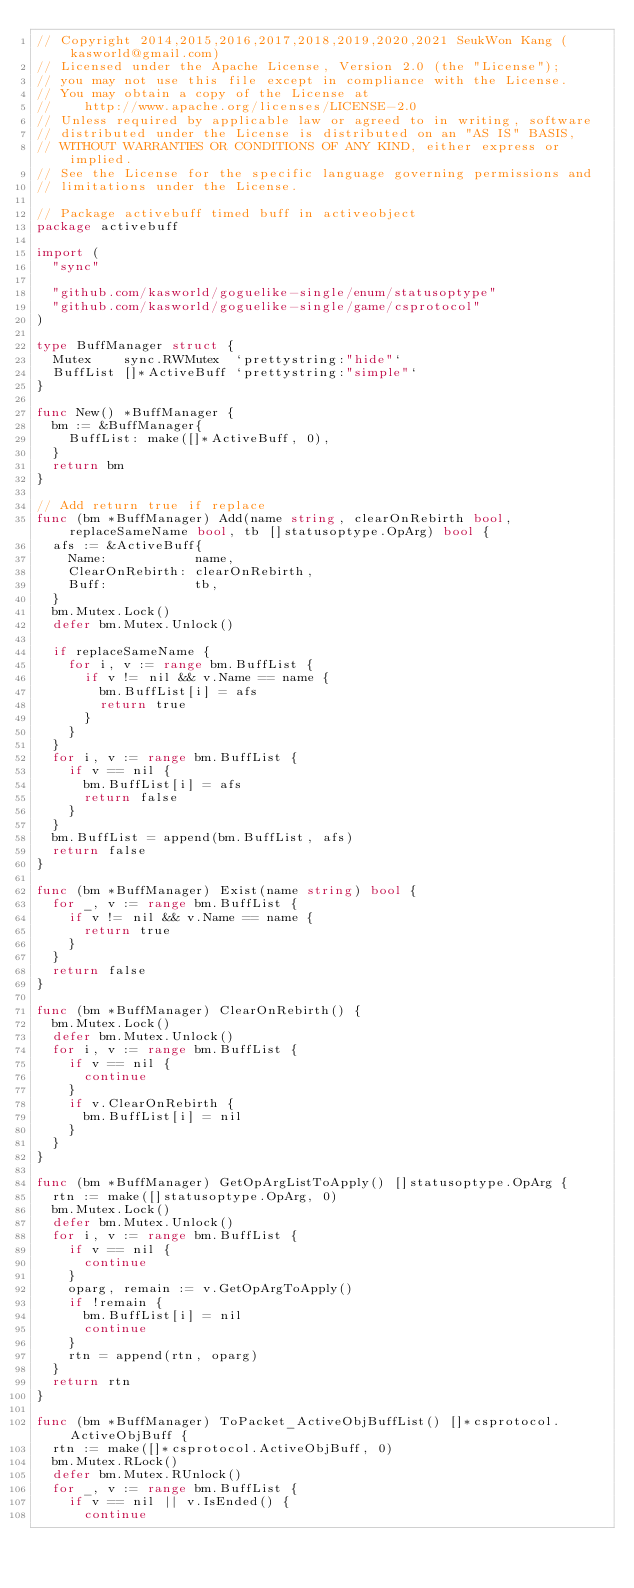Convert code to text. <code><loc_0><loc_0><loc_500><loc_500><_Go_>// Copyright 2014,2015,2016,2017,2018,2019,2020,2021 SeukWon Kang (kasworld@gmail.com)
// Licensed under the Apache License, Version 2.0 (the "License");
// you may not use this file except in compliance with the License.
// You may obtain a copy of the License at
//    http://www.apache.org/licenses/LICENSE-2.0
// Unless required by applicable law or agreed to in writing, software
// distributed under the License is distributed on an "AS IS" BASIS,
// WITHOUT WARRANTIES OR CONDITIONS OF ANY KIND, either express or implied.
// See the License for the specific language governing permissions and
// limitations under the License.

// Package activebuff timed buff in activeobject
package activebuff

import (
	"sync"

	"github.com/kasworld/goguelike-single/enum/statusoptype"
	"github.com/kasworld/goguelike-single/game/csprotocol"
)

type BuffManager struct {
	Mutex    sync.RWMutex  `prettystring:"hide"`
	BuffList []*ActiveBuff `prettystring:"simple"`
}

func New() *BuffManager {
	bm := &BuffManager{
		BuffList: make([]*ActiveBuff, 0),
	}
	return bm
}

// Add return true if replace
func (bm *BuffManager) Add(name string, clearOnRebirth bool, replaceSameName bool, tb []statusoptype.OpArg) bool {
	afs := &ActiveBuff{
		Name:           name,
		ClearOnRebirth: clearOnRebirth,
		Buff:           tb,
	}
	bm.Mutex.Lock()
	defer bm.Mutex.Unlock()

	if replaceSameName {
		for i, v := range bm.BuffList {
			if v != nil && v.Name == name {
				bm.BuffList[i] = afs
				return true
			}
		}
	}
	for i, v := range bm.BuffList {
		if v == nil {
			bm.BuffList[i] = afs
			return false
		}
	}
	bm.BuffList = append(bm.BuffList, afs)
	return false
}

func (bm *BuffManager) Exist(name string) bool {
	for _, v := range bm.BuffList {
		if v != nil && v.Name == name {
			return true
		}
	}
	return false
}

func (bm *BuffManager) ClearOnRebirth() {
	bm.Mutex.Lock()
	defer bm.Mutex.Unlock()
	for i, v := range bm.BuffList {
		if v == nil {
			continue
		}
		if v.ClearOnRebirth {
			bm.BuffList[i] = nil
		}
	}
}

func (bm *BuffManager) GetOpArgListToApply() []statusoptype.OpArg {
	rtn := make([]statusoptype.OpArg, 0)
	bm.Mutex.Lock()
	defer bm.Mutex.Unlock()
	for i, v := range bm.BuffList {
		if v == nil {
			continue
		}
		oparg, remain := v.GetOpArgToApply()
		if !remain {
			bm.BuffList[i] = nil
			continue
		}
		rtn = append(rtn, oparg)
	}
	return rtn
}

func (bm *BuffManager) ToPacket_ActiveObjBuffList() []*csprotocol.ActiveObjBuff {
	rtn := make([]*csprotocol.ActiveObjBuff, 0)
	bm.Mutex.RLock()
	defer bm.Mutex.RUnlock()
	for _, v := range bm.BuffList {
		if v == nil || v.IsEnded() {
			continue</code> 